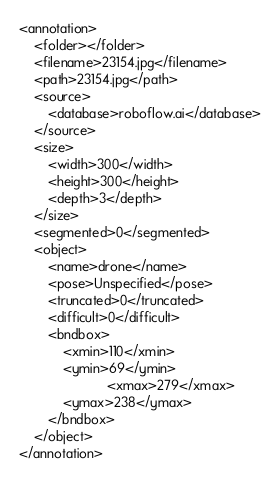Convert code to text. <code><loc_0><loc_0><loc_500><loc_500><_XML_><annotation>
	<folder></folder>
	<filename>23154.jpg</filename>
	<path>23154.jpg</path>
	<source>
		<database>roboflow.ai</database>
	</source>
	<size>
		<width>300</width>
		<height>300</height>
		<depth>3</depth>
	</size>
	<segmented>0</segmented>
	<object>
		<name>drone</name>
		<pose>Unspecified</pose>
		<truncated>0</truncated>
		<difficult>0</difficult>
		<bndbox>
			<xmin>110</xmin>
			<ymin>69</ymin>
                        <xmax>279</xmax>
			<ymax>238</ymax>
		</bndbox>
	</object>
</annotation>
</code> 